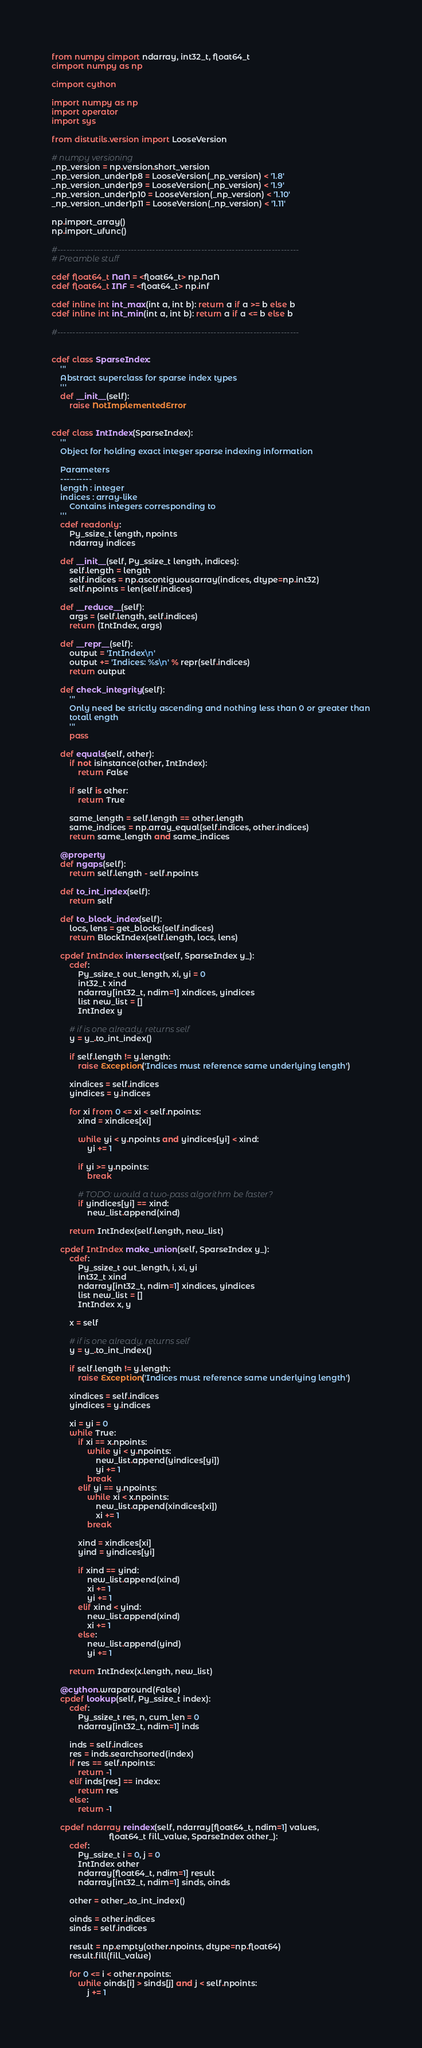Convert code to text. <code><loc_0><loc_0><loc_500><loc_500><_Cython_>from numpy cimport ndarray, int32_t, float64_t
cimport numpy as np

cimport cython

import numpy as np
import operator
import sys

from distutils.version import LooseVersion

# numpy versioning
_np_version = np.version.short_version
_np_version_under1p8 = LooseVersion(_np_version) < '1.8'
_np_version_under1p9 = LooseVersion(_np_version) < '1.9'
_np_version_under1p10 = LooseVersion(_np_version) < '1.10'
_np_version_under1p11 = LooseVersion(_np_version) < '1.11'

np.import_array()
np.import_ufunc()

#-------------------------------------------------------------------------------
# Preamble stuff

cdef float64_t NaN = <float64_t> np.NaN
cdef float64_t INF = <float64_t> np.inf

cdef inline int int_max(int a, int b): return a if a >= b else b
cdef inline int int_min(int a, int b): return a if a <= b else b

#-------------------------------------------------------------------------------


cdef class SparseIndex:
    '''
    Abstract superclass for sparse index types
    '''
    def __init__(self):
        raise NotImplementedError


cdef class IntIndex(SparseIndex):
    '''
    Object for holding exact integer sparse indexing information

    Parameters
    ----------
    length : integer
    indices : array-like
        Contains integers corresponding to
    '''
    cdef readonly:
        Py_ssize_t length, npoints
        ndarray indices

    def __init__(self, Py_ssize_t length, indices):
        self.length = length
        self.indices = np.ascontiguousarray(indices, dtype=np.int32)
        self.npoints = len(self.indices)

    def __reduce__(self):
        args = (self.length, self.indices)
        return (IntIndex, args)

    def __repr__(self):
        output = 'IntIndex\n'
        output += 'Indices: %s\n' % repr(self.indices)
        return output

    def check_integrity(self):
        '''
        Only need be strictly ascending and nothing less than 0 or greater than
        totall ength
        '''
        pass

    def equals(self, other):
        if not isinstance(other, IntIndex):
            return False

        if self is other:
            return True

        same_length = self.length == other.length
        same_indices = np.array_equal(self.indices, other.indices)
        return same_length and same_indices

    @property
    def ngaps(self):
        return self.length - self.npoints

    def to_int_index(self):
        return self

    def to_block_index(self):
        locs, lens = get_blocks(self.indices)
        return BlockIndex(self.length, locs, lens)

    cpdef IntIndex intersect(self, SparseIndex y_):
        cdef:
            Py_ssize_t out_length, xi, yi = 0
            int32_t xind
            ndarray[int32_t, ndim=1] xindices, yindices
            list new_list = []
            IntIndex y

        # if is one already, returns self
        y = y_.to_int_index()

        if self.length != y.length:
            raise Exception('Indices must reference same underlying length')

        xindices = self.indices
        yindices = y.indices

        for xi from 0 <= xi < self.npoints:
            xind = xindices[xi]

            while yi < y.npoints and yindices[yi] < xind:
                yi += 1

            if yi >= y.npoints:
                break

            # TODO: would a two-pass algorithm be faster?
            if yindices[yi] == xind:
                new_list.append(xind)

        return IntIndex(self.length, new_list)

    cpdef IntIndex make_union(self, SparseIndex y_):
        cdef:
            Py_ssize_t out_length, i, xi, yi
            int32_t xind
            ndarray[int32_t, ndim=1] xindices, yindices
            list new_list = []
            IntIndex x, y

        x = self

        # if is one already, returns self
        y = y_.to_int_index()

        if self.length != y.length:
            raise Exception('Indices must reference same underlying length')

        xindices = self.indices
        yindices = y.indices

        xi = yi = 0
        while True:
            if xi == x.npoints:
                while yi < y.npoints:
                    new_list.append(yindices[yi])
                    yi += 1
                break
            elif yi == y.npoints:
                while xi < x.npoints:
                    new_list.append(xindices[xi])
                    xi += 1
                break

            xind = xindices[xi]
            yind = yindices[yi]

            if xind == yind:
                new_list.append(xind)
                xi += 1
                yi += 1
            elif xind < yind:
                new_list.append(xind)
                xi += 1
            else:
                new_list.append(yind)
                yi += 1

        return IntIndex(x.length, new_list)

    @cython.wraparound(False)
    cpdef lookup(self, Py_ssize_t index):
        cdef:
            Py_ssize_t res, n, cum_len = 0
            ndarray[int32_t, ndim=1] inds

        inds = self.indices
        res = inds.searchsorted(index)
        if res == self.npoints:
            return -1
        elif inds[res] == index:
            return res
        else:
            return -1

    cpdef ndarray reindex(self, ndarray[float64_t, ndim=1] values,
                          float64_t fill_value, SparseIndex other_):
        cdef:
            Py_ssize_t i = 0, j = 0
            IntIndex other
            ndarray[float64_t, ndim=1] result
            ndarray[int32_t, ndim=1] sinds, oinds

        other = other_.to_int_index()

        oinds = other.indices
        sinds = self.indices

        result = np.empty(other.npoints, dtype=np.float64)
        result.fill(fill_value)

        for 0 <= i < other.npoints:
            while oinds[i] > sinds[j] and j < self.npoints:
                j += 1
</code> 